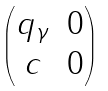<formula> <loc_0><loc_0><loc_500><loc_500>\begin{pmatrix} q _ { \gamma } & 0 \\ c & 0 \end{pmatrix}</formula> 